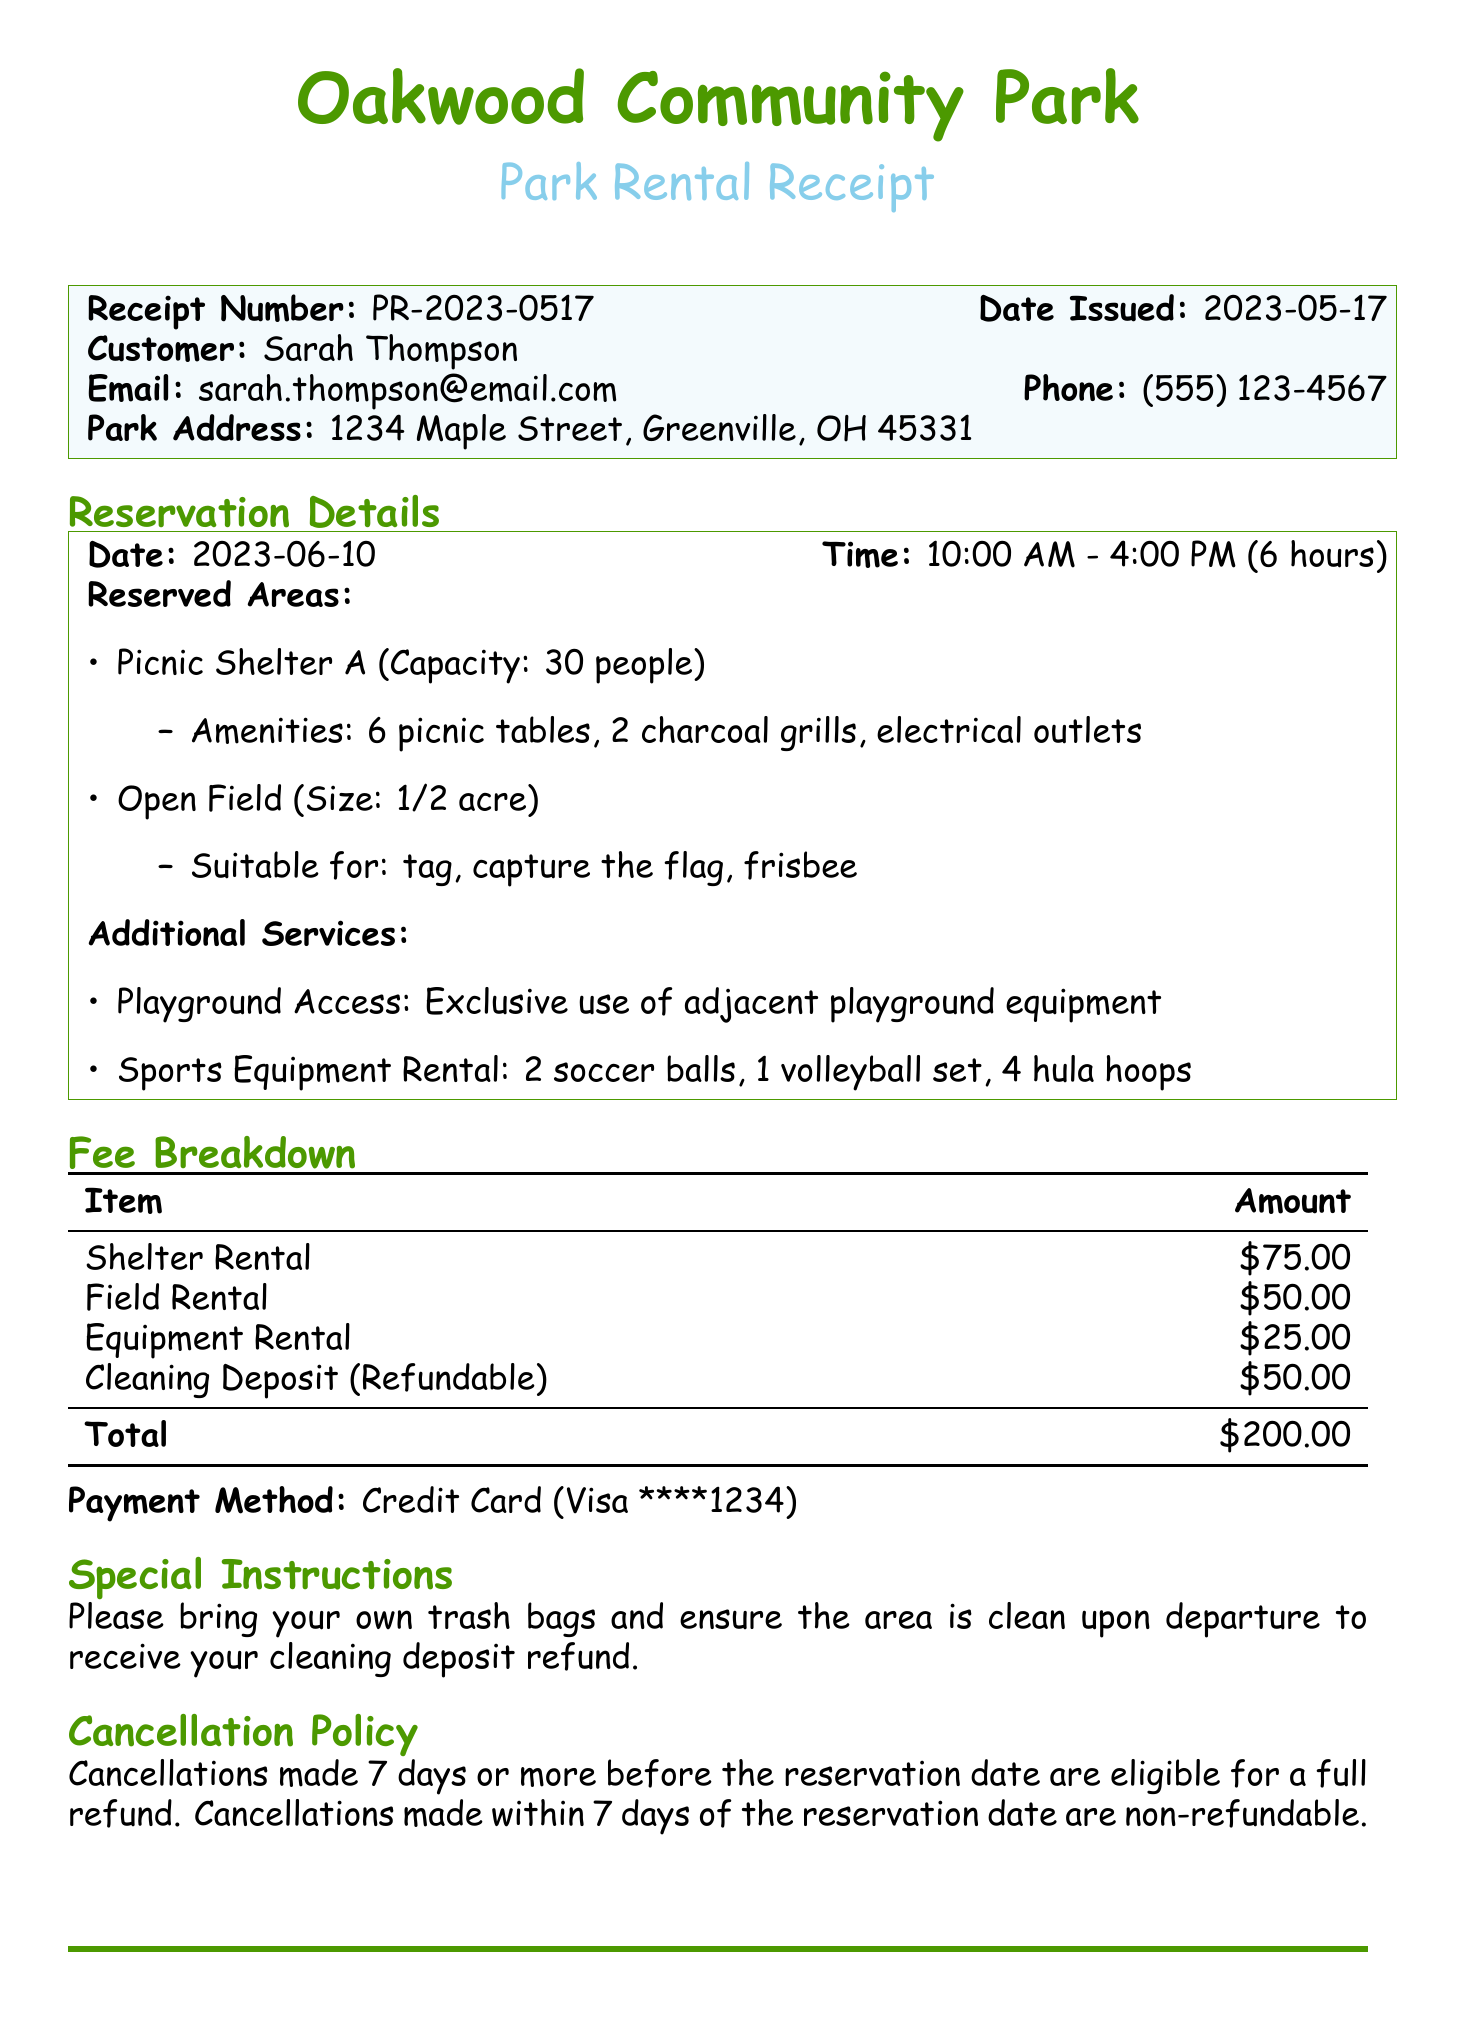What is the receipt number? The receipt number is provided for tracking the reservation, which is PR-2023-0517.
Answer: PR-2023-0517 What is the reservation date? The reservation date is specified in the document under reservation details, which is June 10, 2023.
Answer: June 10, 2023 What time does the reservation start? The start time of the reservation is included in the document, which is 10:00 AM.
Answer: 10:00 AM How many picnic tables are included in the amenities? The number of picnic tables is listed under reserved areas, which states there are 6 picnic tables.
Answer: 6 picnic tables What is the total amount for the park rental? The total amount for the rental is summarized in the fee breakdown section, which is $200.00.
Answer: $200.00 What equipment is included in the sports equipment rental? The items included in the sports equipment rental are listed in the additional services section, which includes 2 soccer balls, 1 volleyball set, and 4 hula hoops.
Answer: 2 soccer balls, 1 volleyball set, 4 hula hoops What is required to receive the cleaning deposit refund? The document specifies the special instructions regarding the cleaning deposit, which states that the area must be clean upon departure.
Answer: Must be clean upon departure Is alcohol allowed in the park? The park rules section states the policy regarding alcohol, which specifically mentions that no alcohol or glass containers are permitted.
Answer: No Who should be contacted in case of an emergency? The emergency contact information provided in the document is for the Park Ranger Office, indicating they are the point of contact.
Answer: Park Ranger Office 